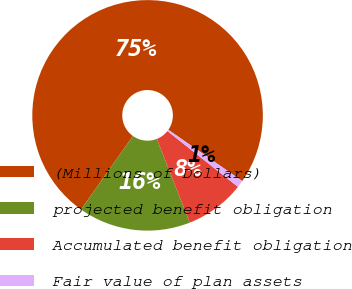Convert chart. <chart><loc_0><loc_0><loc_500><loc_500><pie_chart><fcel>(Millions of Dollars)<fcel>projected benefit obligation<fcel>Accumulated benefit obligation<fcel>Fair value of plan assets<nl><fcel>74.86%<fcel>15.77%<fcel>8.38%<fcel>0.99%<nl></chart> 